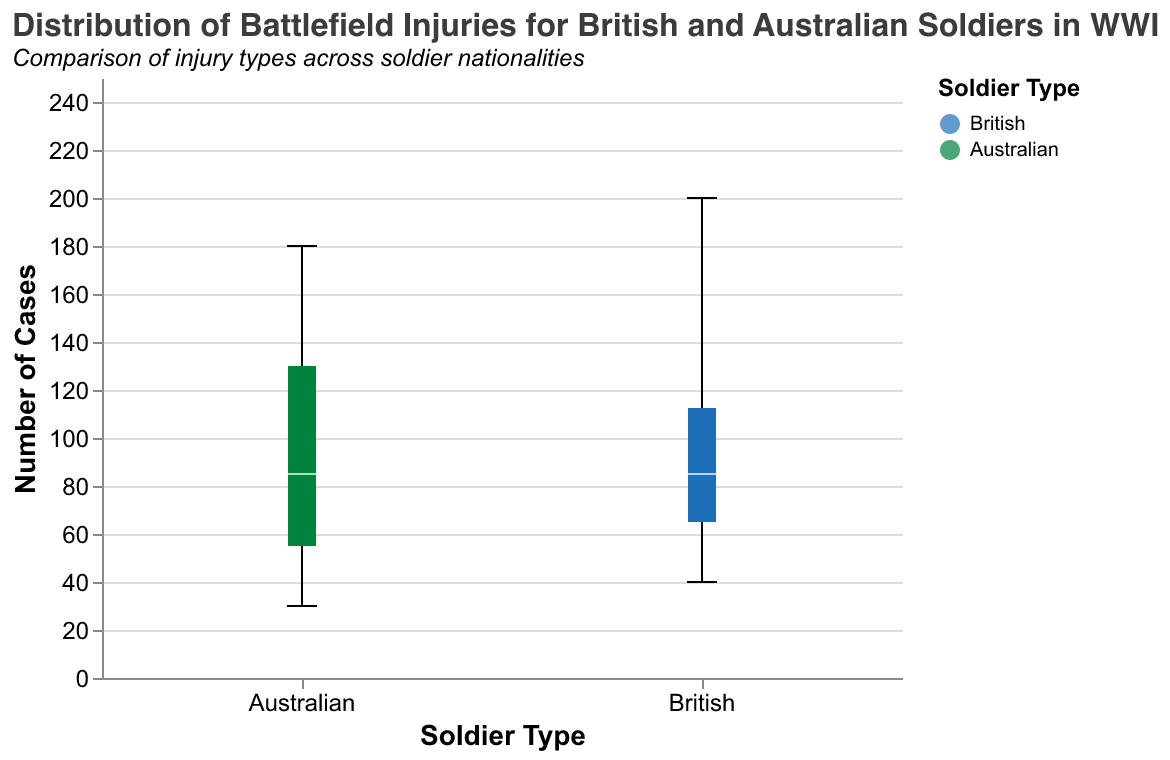What is the title of the figure? The title is usually located at the top of the chart and is easily identifiable. The title of the figure reads, "Distribution of Battlefield Injuries for British and Australian Soldiers in WWI."
Answer: Distribution of Battlefield Injuries for British and Australian Soldiers in WWI What does the y-axis represent? The y-axis usually has a label to indicate what it represents. In this figure, the y-axis represents the "Number of Cases."
Answer: Number of Cases How many types of injuries are documented for British and Australian soldiers? Each injury type will have corresponding box plots for both British and Australian soldiers. By counting the distinct injury types listed, we can determine the number. There are six types of injuries: Shrapnel, Bullet, Gas, TrenchFoot, Bayonet, and Explosive.
Answer: Six Which soldier type has a higher median number of bullet injuries? The median is marked by a white line inside the box plot. By comparing the median lines for the "Bullet" injury type, we can determine which soldier type has a higher median number of bullet injuries. The British soldiers have a higher median number of bullet injuries.
Answer: British soldiers What is the range of the number of gas injuries for Australian soldiers? The range of a box plot is defined by the minimum and maximum values depicted by the whiskers. For the "Gas" injury type for Australian soldiers, the minimum value is at one end of the whisker and the maximum value is at the other. The range of gas injuries for Australian soldiers is between 70 and 70.
Answer: 70 to 70 Which type of injury has the most cases for British soldiers? By looking at the heights of the boxes and whiskers for all injury types for British soldiers, we can identify the type with the highest maximum value. "Bullet" injuries have the highest number of cases for British soldiers, reaching up to 200.
Answer: Bullet How do the maximum number of shrapnel injuries compare between British and Australian soldiers? By comparing the upper whiskers (representing the maximum) of the "Shrapnel" injury type across both soldier types, we see that Australian soldiers have a higher maximum number of shrapnel injuries (140) compared to British soldiers (120).
Answer: Australian soldiers have more What is the interquartile range (IQR) for bullet injuries for British soldiers? The IQR is the range between the first quartile (lower edge of the box) and the third quartile (upper edge of the box). In a detailed analysis of the bullet injuries for British soldiers, assign the numerical values from the range depicted. Since the figure doesn't provide the explicit quartile values, answering this requires visual approximation. But it involves subtracting the lower quartile from the upper quartile.
Answer: Not explicitly calculable without more detail Which injury type shows the least number of cases overall? By examining the lower whiskers (depicting the minimum values) and the heights of boxes, we can identify the injury type with the least number of cases. "Bayonet" injuries, with 30 cases, are the least frequent.
Answer: Bayonet 